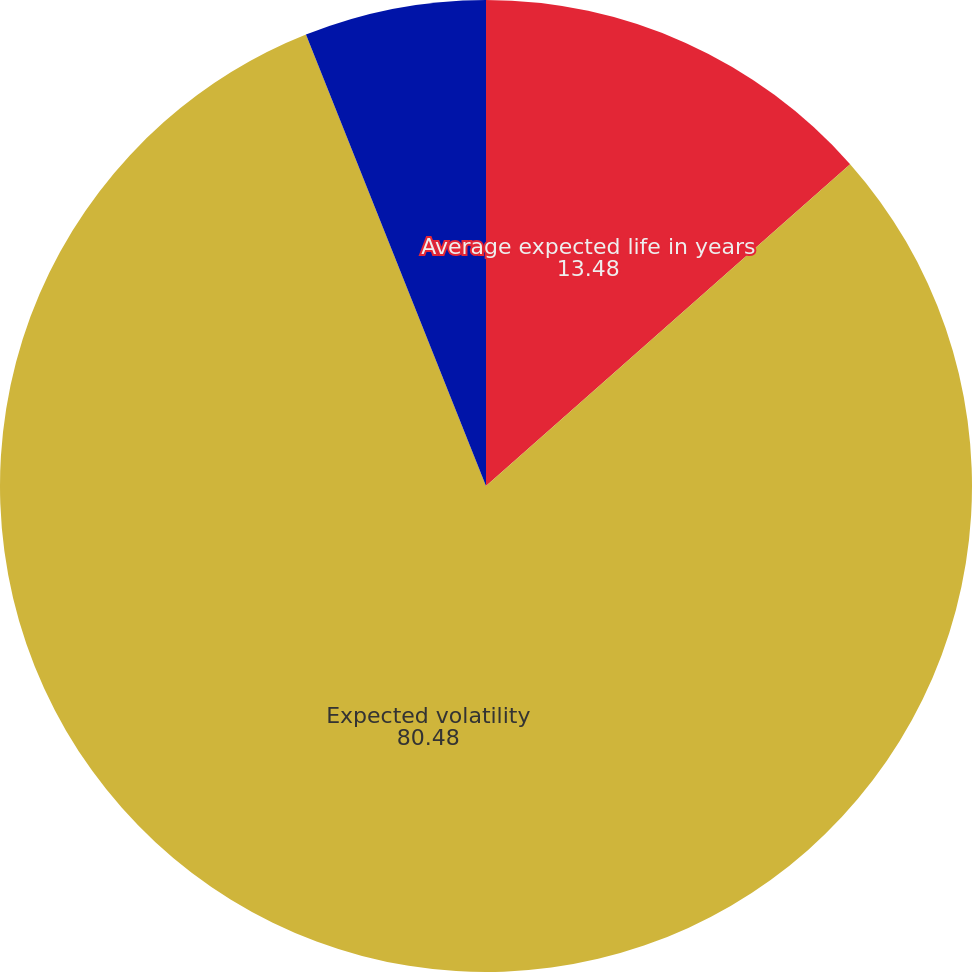Convert chart to OTSL. <chart><loc_0><loc_0><loc_500><loc_500><pie_chart><fcel>Average expected life in years<fcel>Expected volatility<fcel>Risk-free interest rate (zero<nl><fcel>13.48%<fcel>80.48%<fcel>6.04%<nl></chart> 